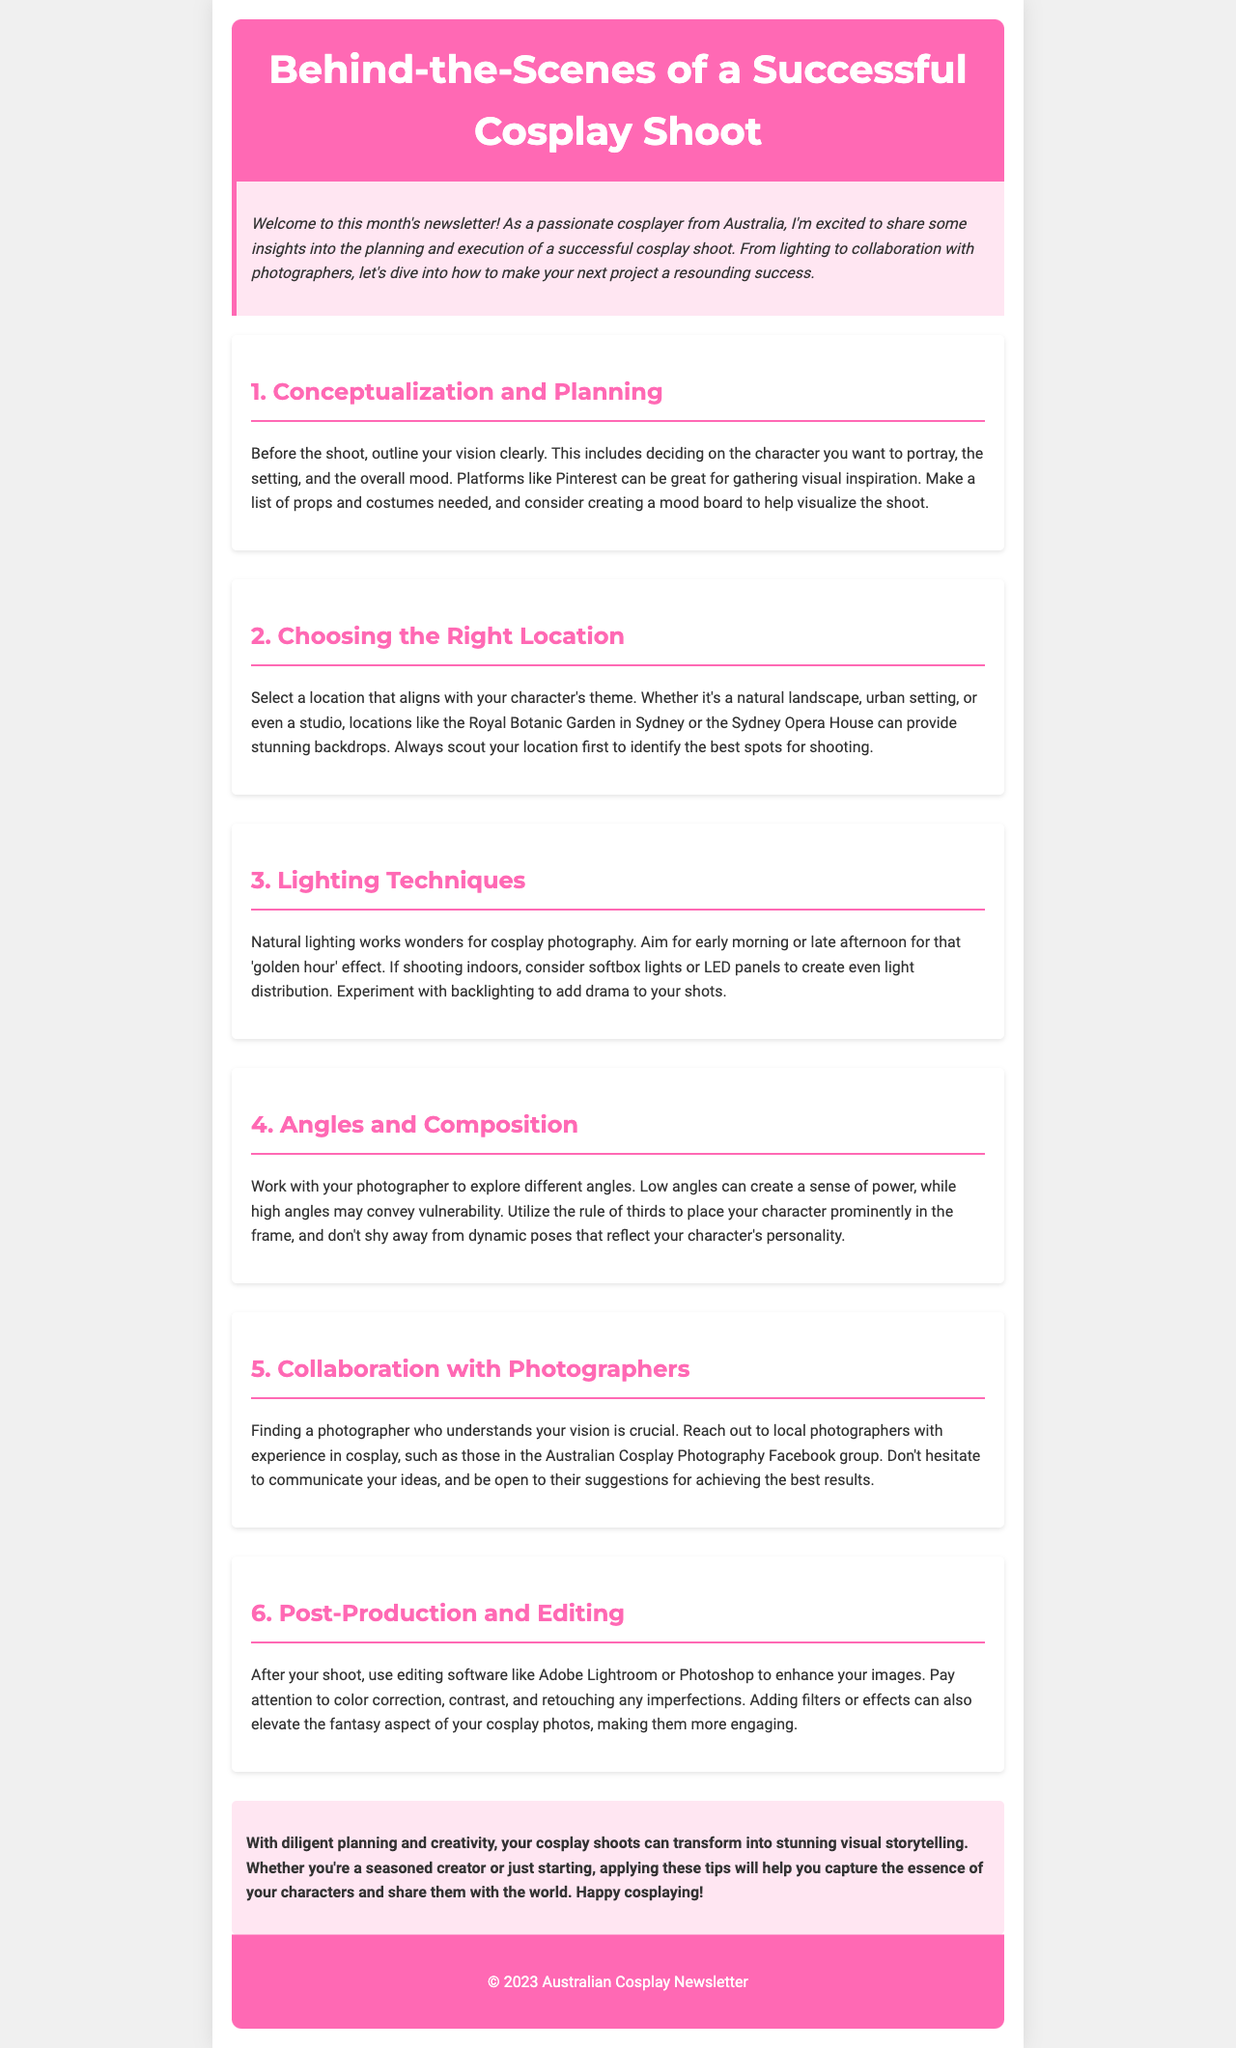What is the title of the newsletter? The title of the newsletter is highlighted in the header section of the document.
Answer: Behind-the-Scenes of a Successful Cosplay Shoot Who is the newsletter targeted towards? The introduction specifies that the newsletter is aimed at passionate cosplayers from Australia.
Answer: Cosplayers Which location is mentioned as a backdrop for shoots? The document provides examples of locations that are suitable for cosplay shoots, including specific places in Australia.
Answer: Royal Botanic Garden in Sydney What time of day is suggested for natural lighting? The lighting techniques section describes an optimal time for natural lighting during a shoot.
Answer: Early morning or late afternoon What editing software is mentioned in the post-production section? The document states specific software that can enhance images after a cosplay shoot.
Answer: Adobe Lightroom or Photoshop How should angles be explored during the shoot? The angles and composition section emphasizes collaboration with the photographer.
Answer: Work with your photographer What is the importance of mood boards according to the planning section? The conceptualization and planning section mentions the use of mood boards for visualization.
Answer: Help visualize the shoot What is the overall tone of the newsletter? The introduction conveys the writer's enthusiasm and excitement for sharing insights into cosplay shoots.
Answer: Excited and informative 